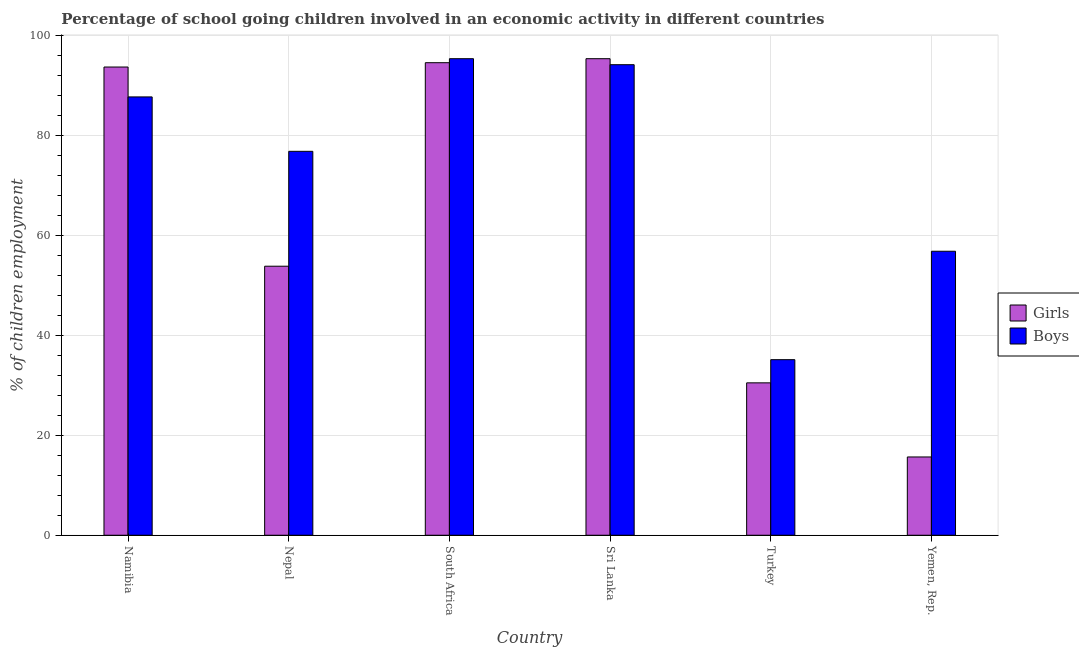How many groups of bars are there?
Offer a very short reply. 6. Are the number of bars on each tick of the X-axis equal?
Provide a short and direct response. Yes. What is the label of the 5th group of bars from the left?
Ensure brevity in your answer.  Turkey. In how many cases, is the number of bars for a given country not equal to the number of legend labels?
Give a very brief answer. 0. What is the percentage of school going boys in Turkey?
Make the answer very short. 35.11. Across all countries, what is the maximum percentage of school going girls?
Give a very brief answer. 95.3. Across all countries, what is the minimum percentage of school going girls?
Give a very brief answer. 15.66. In which country was the percentage of school going girls maximum?
Your answer should be compact. Sri Lanka. In which country was the percentage of school going girls minimum?
Give a very brief answer. Yemen, Rep. What is the total percentage of school going girls in the graph?
Offer a terse response. 383.37. What is the difference between the percentage of school going boys in Sri Lanka and that in Turkey?
Offer a terse response. 58.99. What is the average percentage of school going boys per country?
Keep it short and to the point. 74.29. What is the difference between the percentage of school going boys and percentage of school going girls in Sri Lanka?
Provide a succinct answer. -1.2. What is the ratio of the percentage of school going girls in Namibia to that in Nepal?
Provide a short and direct response. 1.74. Is the percentage of school going boys in Namibia less than that in Sri Lanka?
Provide a short and direct response. Yes. Is the difference between the percentage of school going boys in Nepal and Turkey greater than the difference between the percentage of school going girls in Nepal and Turkey?
Ensure brevity in your answer.  Yes. What is the difference between the highest and the second highest percentage of school going girls?
Ensure brevity in your answer.  0.8. What is the difference between the highest and the lowest percentage of school going girls?
Provide a short and direct response. 79.64. Is the sum of the percentage of school going boys in Namibia and Turkey greater than the maximum percentage of school going girls across all countries?
Your answer should be compact. Yes. What does the 2nd bar from the left in Yemen, Rep. represents?
Ensure brevity in your answer.  Boys. What does the 1st bar from the right in Nepal represents?
Your response must be concise. Boys. How many bars are there?
Your answer should be compact. 12. Are all the bars in the graph horizontal?
Provide a succinct answer. No. How many countries are there in the graph?
Your response must be concise. 6. Are the values on the major ticks of Y-axis written in scientific E-notation?
Keep it short and to the point. No. How many legend labels are there?
Provide a short and direct response. 2. What is the title of the graph?
Your answer should be compact. Percentage of school going children involved in an economic activity in different countries. Does "Primary completion rate" appear as one of the legend labels in the graph?
Provide a succinct answer. No. What is the label or title of the X-axis?
Ensure brevity in your answer.  Country. What is the label or title of the Y-axis?
Ensure brevity in your answer.  % of children employment. What is the % of children employment in Girls in Namibia?
Your answer should be very brief. 93.64. What is the % of children employment of Boys in Namibia?
Your response must be concise. 87.66. What is the % of children employment in Girls in Nepal?
Offer a very short reply. 53.8. What is the % of children employment of Boys in Nepal?
Give a very brief answer. 76.78. What is the % of children employment in Girls in South Africa?
Make the answer very short. 94.5. What is the % of children employment in Boys in South Africa?
Your response must be concise. 95.3. What is the % of children employment in Girls in Sri Lanka?
Offer a terse response. 95.3. What is the % of children employment of Boys in Sri Lanka?
Your response must be concise. 94.1. What is the % of children employment in Girls in Turkey?
Offer a terse response. 30.48. What is the % of children employment in Boys in Turkey?
Provide a short and direct response. 35.11. What is the % of children employment of Girls in Yemen, Rep.?
Your answer should be compact. 15.66. What is the % of children employment in Boys in Yemen, Rep.?
Give a very brief answer. 56.8. Across all countries, what is the maximum % of children employment of Girls?
Your response must be concise. 95.3. Across all countries, what is the maximum % of children employment of Boys?
Your answer should be very brief. 95.3. Across all countries, what is the minimum % of children employment of Girls?
Keep it short and to the point. 15.66. Across all countries, what is the minimum % of children employment in Boys?
Your answer should be very brief. 35.11. What is the total % of children employment of Girls in the graph?
Keep it short and to the point. 383.37. What is the total % of children employment of Boys in the graph?
Your response must be concise. 445.74. What is the difference between the % of children employment in Girls in Namibia and that in Nepal?
Keep it short and to the point. 39.84. What is the difference between the % of children employment in Boys in Namibia and that in Nepal?
Ensure brevity in your answer.  10.88. What is the difference between the % of children employment of Girls in Namibia and that in South Africa?
Your response must be concise. -0.86. What is the difference between the % of children employment of Boys in Namibia and that in South Africa?
Give a very brief answer. -7.64. What is the difference between the % of children employment of Girls in Namibia and that in Sri Lanka?
Offer a very short reply. -1.66. What is the difference between the % of children employment of Boys in Namibia and that in Sri Lanka?
Make the answer very short. -6.44. What is the difference between the % of children employment of Girls in Namibia and that in Turkey?
Offer a very short reply. 63.16. What is the difference between the % of children employment of Boys in Namibia and that in Turkey?
Your answer should be compact. 52.54. What is the difference between the % of children employment in Girls in Namibia and that in Yemen, Rep.?
Offer a very short reply. 77.98. What is the difference between the % of children employment of Boys in Namibia and that in Yemen, Rep.?
Ensure brevity in your answer.  30.86. What is the difference between the % of children employment of Girls in Nepal and that in South Africa?
Ensure brevity in your answer.  -40.7. What is the difference between the % of children employment of Boys in Nepal and that in South Africa?
Offer a terse response. -18.52. What is the difference between the % of children employment in Girls in Nepal and that in Sri Lanka?
Keep it short and to the point. -41.5. What is the difference between the % of children employment in Boys in Nepal and that in Sri Lanka?
Your response must be concise. -17.32. What is the difference between the % of children employment in Girls in Nepal and that in Turkey?
Provide a succinct answer. 23.32. What is the difference between the % of children employment of Boys in Nepal and that in Turkey?
Offer a terse response. 41.66. What is the difference between the % of children employment of Girls in Nepal and that in Yemen, Rep.?
Your answer should be compact. 38.14. What is the difference between the % of children employment in Boys in Nepal and that in Yemen, Rep.?
Your answer should be very brief. 19.98. What is the difference between the % of children employment of Girls in South Africa and that in Sri Lanka?
Offer a terse response. -0.8. What is the difference between the % of children employment in Boys in South Africa and that in Sri Lanka?
Offer a very short reply. 1.2. What is the difference between the % of children employment of Girls in South Africa and that in Turkey?
Offer a very short reply. 64.02. What is the difference between the % of children employment in Boys in South Africa and that in Turkey?
Your response must be concise. 60.19. What is the difference between the % of children employment of Girls in South Africa and that in Yemen, Rep.?
Your response must be concise. 78.84. What is the difference between the % of children employment of Boys in South Africa and that in Yemen, Rep.?
Your answer should be very brief. 38.5. What is the difference between the % of children employment in Girls in Sri Lanka and that in Turkey?
Your answer should be compact. 64.82. What is the difference between the % of children employment in Boys in Sri Lanka and that in Turkey?
Ensure brevity in your answer.  58.99. What is the difference between the % of children employment of Girls in Sri Lanka and that in Yemen, Rep.?
Your answer should be compact. 79.64. What is the difference between the % of children employment of Boys in Sri Lanka and that in Yemen, Rep.?
Provide a short and direct response. 37.3. What is the difference between the % of children employment of Girls in Turkey and that in Yemen, Rep.?
Make the answer very short. 14.82. What is the difference between the % of children employment in Boys in Turkey and that in Yemen, Rep.?
Offer a very short reply. -21.68. What is the difference between the % of children employment in Girls in Namibia and the % of children employment in Boys in Nepal?
Offer a very short reply. 16.86. What is the difference between the % of children employment in Girls in Namibia and the % of children employment in Boys in South Africa?
Offer a terse response. -1.66. What is the difference between the % of children employment of Girls in Namibia and the % of children employment of Boys in Sri Lanka?
Provide a succinct answer. -0.46. What is the difference between the % of children employment in Girls in Namibia and the % of children employment in Boys in Turkey?
Your answer should be very brief. 58.52. What is the difference between the % of children employment of Girls in Namibia and the % of children employment of Boys in Yemen, Rep.?
Provide a short and direct response. 36.84. What is the difference between the % of children employment in Girls in Nepal and the % of children employment in Boys in South Africa?
Ensure brevity in your answer.  -41.5. What is the difference between the % of children employment in Girls in Nepal and the % of children employment in Boys in Sri Lanka?
Make the answer very short. -40.3. What is the difference between the % of children employment in Girls in Nepal and the % of children employment in Boys in Turkey?
Provide a succinct answer. 18.69. What is the difference between the % of children employment of Girls in Nepal and the % of children employment of Boys in Yemen, Rep.?
Offer a very short reply. -3. What is the difference between the % of children employment in Girls in South Africa and the % of children employment in Boys in Turkey?
Ensure brevity in your answer.  59.39. What is the difference between the % of children employment of Girls in South Africa and the % of children employment of Boys in Yemen, Rep.?
Keep it short and to the point. 37.7. What is the difference between the % of children employment of Girls in Sri Lanka and the % of children employment of Boys in Turkey?
Make the answer very short. 60.19. What is the difference between the % of children employment of Girls in Sri Lanka and the % of children employment of Boys in Yemen, Rep.?
Your answer should be compact. 38.5. What is the difference between the % of children employment in Girls in Turkey and the % of children employment in Boys in Yemen, Rep.?
Keep it short and to the point. -26.32. What is the average % of children employment of Girls per country?
Provide a succinct answer. 63.89. What is the average % of children employment of Boys per country?
Ensure brevity in your answer.  74.29. What is the difference between the % of children employment in Girls and % of children employment in Boys in Namibia?
Ensure brevity in your answer.  5.98. What is the difference between the % of children employment in Girls and % of children employment in Boys in Nepal?
Your response must be concise. -22.98. What is the difference between the % of children employment in Girls and % of children employment in Boys in South Africa?
Your answer should be very brief. -0.8. What is the difference between the % of children employment of Girls and % of children employment of Boys in Turkey?
Give a very brief answer. -4.64. What is the difference between the % of children employment in Girls and % of children employment in Boys in Yemen, Rep.?
Offer a terse response. -41.14. What is the ratio of the % of children employment of Girls in Namibia to that in Nepal?
Give a very brief answer. 1.74. What is the ratio of the % of children employment of Boys in Namibia to that in Nepal?
Ensure brevity in your answer.  1.14. What is the ratio of the % of children employment in Girls in Namibia to that in South Africa?
Make the answer very short. 0.99. What is the ratio of the % of children employment of Boys in Namibia to that in South Africa?
Your response must be concise. 0.92. What is the ratio of the % of children employment in Girls in Namibia to that in Sri Lanka?
Provide a short and direct response. 0.98. What is the ratio of the % of children employment in Boys in Namibia to that in Sri Lanka?
Offer a terse response. 0.93. What is the ratio of the % of children employment of Girls in Namibia to that in Turkey?
Provide a short and direct response. 3.07. What is the ratio of the % of children employment of Boys in Namibia to that in Turkey?
Offer a very short reply. 2.5. What is the ratio of the % of children employment in Girls in Namibia to that in Yemen, Rep.?
Your response must be concise. 5.98. What is the ratio of the % of children employment in Boys in Namibia to that in Yemen, Rep.?
Provide a succinct answer. 1.54. What is the ratio of the % of children employment in Girls in Nepal to that in South Africa?
Offer a very short reply. 0.57. What is the ratio of the % of children employment in Boys in Nepal to that in South Africa?
Offer a very short reply. 0.81. What is the ratio of the % of children employment in Girls in Nepal to that in Sri Lanka?
Offer a terse response. 0.56. What is the ratio of the % of children employment in Boys in Nepal to that in Sri Lanka?
Make the answer very short. 0.82. What is the ratio of the % of children employment of Girls in Nepal to that in Turkey?
Give a very brief answer. 1.77. What is the ratio of the % of children employment in Boys in Nepal to that in Turkey?
Your answer should be compact. 2.19. What is the ratio of the % of children employment in Girls in Nepal to that in Yemen, Rep.?
Provide a succinct answer. 3.44. What is the ratio of the % of children employment of Boys in Nepal to that in Yemen, Rep.?
Offer a terse response. 1.35. What is the ratio of the % of children employment of Boys in South Africa to that in Sri Lanka?
Offer a terse response. 1.01. What is the ratio of the % of children employment in Girls in South Africa to that in Turkey?
Give a very brief answer. 3.1. What is the ratio of the % of children employment of Boys in South Africa to that in Turkey?
Offer a very short reply. 2.71. What is the ratio of the % of children employment in Girls in South Africa to that in Yemen, Rep.?
Your response must be concise. 6.04. What is the ratio of the % of children employment in Boys in South Africa to that in Yemen, Rep.?
Provide a succinct answer. 1.68. What is the ratio of the % of children employment of Girls in Sri Lanka to that in Turkey?
Ensure brevity in your answer.  3.13. What is the ratio of the % of children employment of Boys in Sri Lanka to that in Turkey?
Your answer should be compact. 2.68. What is the ratio of the % of children employment of Girls in Sri Lanka to that in Yemen, Rep.?
Keep it short and to the point. 6.09. What is the ratio of the % of children employment in Boys in Sri Lanka to that in Yemen, Rep.?
Offer a terse response. 1.66. What is the ratio of the % of children employment of Girls in Turkey to that in Yemen, Rep.?
Provide a succinct answer. 1.95. What is the ratio of the % of children employment of Boys in Turkey to that in Yemen, Rep.?
Keep it short and to the point. 0.62. What is the difference between the highest and the second highest % of children employment of Girls?
Provide a short and direct response. 0.8. What is the difference between the highest and the second highest % of children employment in Boys?
Your answer should be compact. 1.2. What is the difference between the highest and the lowest % of children employment of Girls?
Offer a very short reply. 79.64. What is the difference between the highest and the lowest % of children employment in Boys?
Offer a very short reply. 60.19. 